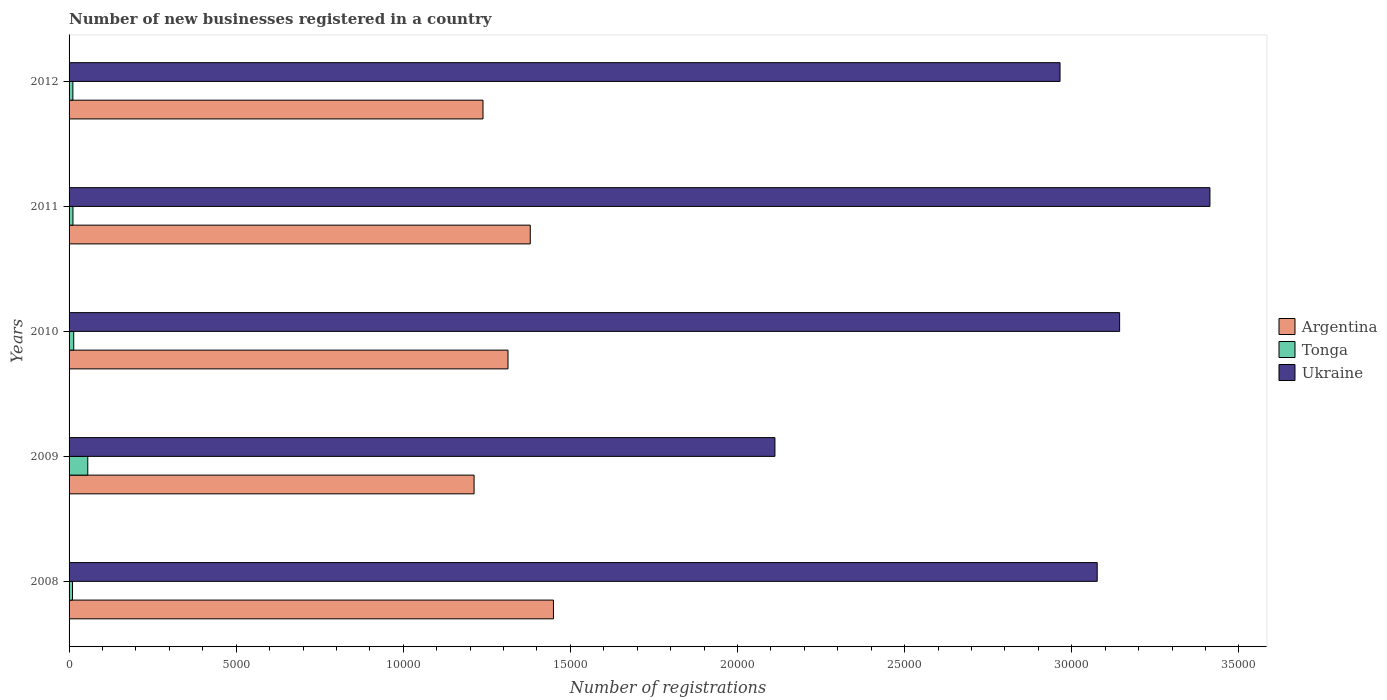How many different coloured bars are there?
Provide a succinct answer. 3. How many groups of bars are there?
Offer a very short reply. 5. Are the number of bars per tick equal to the number of legend labels?
Ensure brevity in your answer.  Yes. What is the number of new businesses registered in Ukraine in 2009?
Ensure brevity in your answer.  2.11e+04. Across all years, what is the maximum number of new businesses registered in Argentina?
Your answer should be compact. 1.45e+04. Across all years, what is the minimum number of new businesses registered in Ukraine?
Offer a very short reply. 2.11e+04. In which year was the number of new businesses registered in Argentina minimum?
Give a very brief answer. 2009. What is the total number of new businesses registered in Tonga in the graph?
Make the answer very short. 1032. What is the difference between the number of new businesses registered in Tonga in 2011 and that in 2012?
Provide a short and direct response. 2. What is the difference between the number of new businesses registered in Argentina in 2011 and the number of new businesses registered in Ukraine in 2008?
Your answer should be compact. -1.70e+04. What is the average number of new businesses registered in Ukraine per year?
Provide a succinct answer. 2.94e+04. In the year 2012, what is the difference between the number of new businesses registered in Argentina and number of new businesses registered in Tonga?
Provide a short and direct response. 1.23e+04. In how many years, is the number of new businesses registered in Argentina greater than 13000 ?
Offer a very short reply. 3. What is the ratio of the number of new businesses registered in Ukraine in 2008 to that in 2011?
Ensure brevity in your answer.  0.9. What is the difference between the highest and the second highest number of new businesses registered in Argentina?
Your answer should be very brief. 694. What is the difference between the highest and the lowest number of new businesses registered in Ukraine?
Keep it short and to the point. 1.30e+04. What does the 2nd bar from the top in 2008 represents?
Provide a succinct answer. Tonga. What does the 3rd bar from the bottom in 2008 represents?
Provide a succinct answer. Ukraine. Is it the case that in every year, the sum of the number of new businesses registered in Tonga and number of new businesses registered in Argentina is greater than the number of new businesses registered in Ukraine?
Keep it short and to the point. No. How many bars are there?
Your answer should be very brief. 15. Are all the bars in the graph horizontal?
Keep it short and to the point. Yes. Are the values on the major ticks of X-axis written in scientific E-notation?
Make the answer very short. No. Does the graph contain any zero values?
Offer a very short reply. No. Does the graph contain grids?
Give a very brief answer. No. How many legend labels are there?
Give a very brief answer. 3. How are the legend labels stacked?
Your answer should be very brief. Vertical. What is the title of the graph?
Give a very brief answer. Number of new businesses registered in a country. Does "Paraguay" appear as one of the legend labels in the graph?
Your response must be concise. No. What is the label or title of the X-axis?
Your response must be concise. Number of registrations. What is the label or title of the Y-axis?
Your response must be concise. Years. What is the Number of registrations of Argentina in 2008?
Offer a terse response. 1.45e+04. What is the Number of registrations of Tonga in 2008?
Provide a succinct answer. 103. What is the Number of registrations in Ukraine in 2008?
Offer a terse response. 3.08e+04. What is the Number of registrations of Argentina in 2009?
Ensure brevity in your answer.  1.21e+04. What is the Number of registrations in Tonga in 2009?
Your response must be concise. 560. What is the Number of registrations of Ukraine in 2009?
Your answer should be very brief. 2.11e+04. What is the Number of registrations in Argentina in 2010?
Your response must be concise. 1.31e+04. What is the Number of registrations in Tonga in 2010?
Provide a succinct answer. 139. What is the Number of registrations of Ukraine in 2010?
Offer a very short reply. 3.14e+04. What is the Number of registrations in Argentina in 2011?
Provide a succinct answer. 1.38e+04. What is the Number of registrations in Tonga in 2011?
Your answer should be compact. 116. What is the Number of registrations in Ukraine in 2011?
Your response must be concise. 3.41e+04. What is the Number of registrations of Argentina in 2012?
Offer a terse response. 1.24e+04. What is the Number of registrations of Tonga in 2012?
Offer a terse response. 114. What is the Number of registrations in Ukraine in 2012?
Provide a short and direct response. 2.96e+04. Across all years, what is the maximum Number of registrations in Argentina?
Give a very brief answer. 1.45e+04. Across all years, what is the maximum Number of registrations of Tonga?
Make the answer very short. 560. Across all years, what is the maximum Number of registrations in Ukraine?
Offer a very short reply. 3.41e+04. Across all years, what is the minimum Number of registrations of Argentina?
Offer a very short reply. 1.21e+04. Across all years, what is the minimum Number of registrations in Tonga?
Your answer should be very brief. 103. Across all years, what is the minimum Number of registrations in Ukraine?
Make the answer very short. 2.11e+04. What is the total Number of registrations in Argentina in the graph?
Keep it short and to the point. 6.59e+04. What is the total Number of registrations of Tonga in the graph?
Your response must be concise. 1032. What is the total Number of registrations in Ukraine in the graph?
Your answer should be compact. 1.47e+05. What is the difference between the Number of registrations in Argentina in 2008 and that in 2009?
Ensure brevity in your answer.  2375. What is the difference between the Number of registrations in Tonga in 2008 and that in 2009?
Give a very brief answer. -457. What is the difference between the Number of registrations in Ukraine in 2008 and that in 2009?
Your response must be concise. 9642. What is the difference between the Number of registrations of Argentina in 2008 and that in 2010?
Your answer should be very brief. 1360. What is the difference between the Number of registrations of Tonga in 2008 and that in 2010?
Offer a very short reply. -36. What is the difference between the Number of registrations of Ukraine in 2008 and that in 2010?
Your answer should be compact. -671. What is the difference between the Number of registrations of Argentina in 2008 and that in 2011?
Offer a terse response. 694. What is the difference between the Number of registrations in Tonga in 2008 and that in 2011?
Provide a short and direct response. -13. What is the difference between the Number of registrations of Ukraine in 2008 and that in 2011?
Give a very brief answer. -3373. What is the difference between the Number of registrations in Argentina in 2008 and that in 2012?
Ensure brevity in your answer.  2108. What is the difference between the Number of registrations in Ukraine in 2008 and that in 2012?
Provide a succinct answer. 1112. What is the difference between the Number of registrations in Argentina in 2009 and that in 2010?
Ensure brevity in your answer.  -1015. What is the difference between the Number of registrations in Tonga in 2009 and that in 2010?
Provide a succinct answer. 421. What is the difference between the Number of registrations in Ukraine in 2009 and that in 2010?
Offer a very short reply. -1.03e+04. What is the difference between the Number of registrations of Argentina in 2009 and that in 2011?
Your answer should be very brief. -1681. What is the difference between the Number of registrations of Tonga in 2009 and that in 2011?
Offer a terse response. 444. What is the difference between the Number of registrations in Ukraine in 2009 and that in 2011?
Your answer should be compact. -1.30e+04. What is the difference between the Number of registrations of Argentina in 2009 and that in 2012?
Your answer should be compact. -267. What is the difference between the Number of registrations of Tonga in 2009 and that in 2012?
Make the answer very short. 446. What is the difference between the Number of registrations of Ukraine in 2009 and that in 2012?
Your answer should be very brief. -8530. What is the difference between the Number of registrations in Argentina in 2010 and that in 2011?
Offer a very short reply. -666. What is the difference between the Number of registrations of Ukraine in 2010 and that in 2011?
Provide a succinct answer. -2702. What is the difference between the Number of registrations of Argentina in 2010 and that in 2012?
Keep it short and to the point. 748. What is the difference between the Number of registrations of Ukraine in 2010 and that in 2012?
Offer a terse response. 1783. What is the difference between the Number of registrations of Argentina in 2011 and that in 2012?
Your answer should be compact. 1414. What is the difference between the Number of registrations in Ukraine in 2011 and that in 2012?
Provide a short and direct response. 4485. What is the difference between the Number of registrations of Argentina in 2008 and the Number of registrations of Tonga in 2009?
Provide a short and direct response. 1.39e+04. What is the difference between the Number of registrations in Argentina in 2008 and the Number of registrations in Ukraine in 2009?
Your answer should be compact. -6627. What is the difference between the Number of registrations in Tonga in 2008 and the Number of registrations in Ukraine in 2009?
Provide a succinct answer. -2.10e+04. What is the difference between the Number of registrations in Argentina in 2008 and the Number of registrations in Tonga in 2010?
Offer a very short reply. 1.44e+04. What is the difference between the Number of registrations in Argentina in 2008 and the Number of registrations in Ukraine in 2010?
Ensure brevity in your answer.  -1.69e+04. What is the difference between the Number of registrations of Tonga in 2008 and the Number of registrations of Ukraine in 2010?
Give a very brief answer. -3.13e+04. What is the difference between the Number of registrations of Argentina in 2008 and the Number of registrations of Tonga in 2011?
Give a very brief answer. 1.44e+04. What is the difference between the Number of registrations of Argentina in 2008 and the Number of registrations of Ukraine in 2011?
Offer a very short reply. -1.96e+04. What is the difference between the Number of registrations of Tonga in 2008 and the Number of registrations of Ukraine in 2011?
Your response must be concise. -3.40e+04. What is the difference between the Number of registrations of Argentina in 2008 and the Number of registrations of Tonga in 2012?
Offer a very short reply. 1.44e+04. What is the difference between the Number of registrations of Argentina in 2008 and the Number of registrations of Ukraine in 2012?
Offer a very short reply. -1.52e+04. What is the difference between the Number of registrations of Tonga in 2008 and the Number of registrations of Ukraine in 2012?
Your answer should be very brief. -2.95e+04. What is the difference between the Number of registrations in Argentina in 2009 and the Number of registrations in Tonga in 2010?
Your answer should be compact. 1.20e+04. What is the difference between the Number of registrations in Argentina in 2009 and the Number of registrations in Ukraine in 2010?
Your answer should be compact. -1.93e+04. What is the difference between the Number of registrations of Tonga in 2009 and the Number of registrations of Ukraine in 2010?
Your answer should be very brief. -3.09e+04. What is the difference between the Number of registrations of Argentina in 2009 and the Number of registrations of Tonga in 2011?
Ensure brevity in your answer.  1.20e+04. What is the difference between the Number of registrations in Argentina in 2009 and the Number of registrations in Ukraine in 2011?
Ensure brevity in your answer.  -2.20e+04. What is the difference between the Number of registrations in Tonga in 2009 and the Number of registrations in Ukraine in 2011?
Your answer should be compact. -3.36e+04. What is the difference between the Number of registrations of Argentina in 2009 and the Number of registrations of Tonga in 2012?
Keep it short and to the point. 1.20e+04. What is the difference between the Number of registrations in Argentina in 2009 and the Number of registrations in Ukraine in 2012?
Make the answer very short. -1.75e+04. What is the difference between the Number of registrations in Tonga in 2009 and the Number of registrations in Ukraine in 2012?
Your response must be concise. -2.91e+04. What is the difference between the Number of registrations of Argentina in 2010 and the Number of registrations of Tonga in 2011?
Provide a succinct answer. 1.30e+04. What is the difference between the Number of registrations of Argentina in 2010 and the Number of registrations of Ukraine in 2011?
Keep it short and to the point. -2.10e+04. What is the difference between the Number of registrations in Tonga in 2010 and the Number of registrations in Ukraine in 2011?
Offer a very short reply. -3.40e+04. What is the difference between the Number of registrations in Argentina in 2010 and the Number of registrations in Tonga in 2012?
Give a very brief answer. 1.30e+04. What is the difference between the Number of registrations in Argentina in 2010 and the Number of registrations in Ukraine in 2012?
Give a very brief answer. -1.65e+04. What is the difference between the Number of registrations of Tonga in 2010 and the Number of registrations of Ukraine in 2012?
Provide a succinct answer. -2.95e+04. What is the difference between the Number of registrations of Argentina in 2011 and the Number of registrations of Tonga in 2012?
Make the answer very short. 1.37e+04. What is the difference between the Number of registrations of Argentina in 2011 and the Number of registrations of Ukraine in 2012?
Make the answer very short. -1.59e+04. What is the difference between the Number of registrations of Tonga in 2011 and the Number of registrations of Ukraine in 2012?
Give a very brief answer. -2.95e+04. What is the average Number of registrations in Argentina per year?
Make the answer very short. 1.32e+04. What is the average Number of registrations of Tonga per year?
Provide a succinct answer. 206.4. What is the average Number of registrations of Ukraine per year?
Your response must be concise. 2.94e+04. In the year 2008, what is the difference between the Number of registrations of Argentina and Number of registrations of Tonga?
Your answer should be very brief. 1.44e+04. In the year 2008, what is the difference between the Number of registrations of Argentina and Number of registrations of Ukraine?
Offer a terse response. -1.63e+04. In the year 2008, what is the difference between the Number of registrations of Tonga and Number of registrations of Ukraine?
Provide a succinct answer. -3.07e+04. In the year 2009, what is the difference between the Number of registrations in Argentina and Number of registrations in Tonga?
Provide a succinct answer. 1.16e+04. In the year 2009, what is the difference between the Number of registrations of Argentina and Number of registrations of Ukraine?
Make the answer very short. -9002. In the year 2009, what is the difference between the Number of registrations in Tonga and Number of registrations in Ukraine?
Provide a succinct answer. -2.06e+04. In the year 2010, what is the difference between the Number of registrations in Argentina and Number of registrations in Tonga?
Your answer should be compact. 1.30e+04. In the year 2010, what is the difference between the Number of registrations of Argentina and Number of registrations of Ukraine?
Your response must be concise. -1.83e+04. In the year 2010, what is the difference between the Number of registrations in Tonga and Number of registrations in Ukraine?
Keep it short and to the point. -3.13e+04. In the year 2011, what is the difference between the Number of registrations in Argentina and Number of registrations in Tonga?
Make the answer very short. 1.37e+04. In the year 2011, what is the difference between the Number of registrations in Argentina and Number of registrations in Ukraine?
Your answer should be compact. -2.03e+04. In the year 2011, what is the difference between the Number of registrations in Tonga and Number of registrations in Ukraine?
Make the answer very short. -3.40e+04. In the year 2012, what is the difference between the Number of registrations of Argentina and Number of registrations of Tonga?
Offer a very short reply. 1.23e+04. In the year 2012, what is the difference between the Number of registrations of Argentina and Number of registrations of Ukraine?
Your response must be concise. -1.73e+04. In the year 2012, what is the difference between the Number of registrations in Tonga and Number of registrations in Ukraine?
Give a very brief answer. -2.95e+04. What is the ratio of the Number of registrations in Argentina in 2008 to that in 2009?
Keep it short and to the point. 1.2. What is the ratio of the Number of registrations in Tonga in 2008 to that in 2009?
Your answer should be compact. 0.18. What is the ratio of the Number of registrations in Ukraine in 2008 to that in 2009?
Your response must be concise. 1.46. What is the ratio of the Number of registrations of Argentina in 2008 to that in 2010?
Provide a succinct answer. 1.1. What is the ratio of the Number of registrations in Tonga in 2008 to that in 2010?
Give a very brief answer. 0.74. What is the ratio of the Number of registrations of Ukraine in 2008 to that in 2010?
Give a very brief answer. 0.98. What is the ratio of the Number of registrations in Argentina in 2008 to that in 2011?
Your answer should be very brief. 1.05. What is the ratio of the Number of registrations of Tonga in 2008 to that in 2011?
Ensure brevity in your answer.  0.89. What is the ratio of the Number of registrations of Ukraine in 2008 to that in 2011?
Your answer should be very brief. 0.9. What is the ratio of the Number of registrations in Argentina in 2008 to that in 2012?
Your answer should be compact. 1.17. What is the ratio of the Number of registrations in Tonga in 2008 to that in 2012?
Your answer should be compact. 0.9. What is the ratio of the Number of registrations in Ukraine in 2008 to that in 2012?
Ensure brevity in your answer.  1.04. What is the ratio of the Number of registrations of Argentina in 2009 to that in 2010?
Make the answer very short. 0.92. What is the ratio of the Number of registrations in Tonga in 2009 to that in 2010?
Ensure brevity in your answer.  4.03. What is the ratio of the Number of registrations in Ukraine in 2009 to that in 2010?
Keep it short and to the point. 0.67. What is the ratio of the Number of registrations of Argentina in 2009 to that in 2011?
Offer a very short reply. 0.88. What is the ratio of the Number of registrations in Tonga in 2009 to that in 2011?
Offer a very short reply. 4.83. What is the ratio of the Number of registrations in Ukraine in 2009 to that in 2011?
Give a very brief answer. 0.62. What is the ratio of the Number of registrations in Argentina in 2009 to that in 2012?
Keep it short and to the point. 0.98. What is the ratio of the Number of registrations in Tonga in 2009 to that in 2012?
Provide a short and direct response. 4.91. What is the ratio of the Number of registrations of Ukraine in 2009 to that in 2012?
Make the answer very short. 0.71. What is the ratio of the Number of registrations in Argentina in 2010 to that in 2011?
Offer a terse response. 0.95. What is the ratio of the Number of registrations of Tonga in 2010 to that in 2011?
Give a very brief answer. 1.2. What is the ratio of the Number of registrations of Ukraine in 2010 to that in 2011?
Offer a terse response. 0.92. What is the ratio of the Number of registrations in Argentina in 2010 to that in 2012?
Ensure brevity in your answer.  1.06. What is the ratio of the Number of registrations in Tonga in 2010 to that in 2012?
Offer a very short reply. 1.22. What is the ratio of the Number of registrations in Ukraine in 2010 to that in 2012?
Offer a very short reply. 1.06. What is the ratio of the Number of registrations of Argentina in 2011 to that in 2012?
Provide a succinct answer. 1.11. What is the ratio of the Number of registrations in Tonga in 2011 to that in 2012?
Offer a very short reply. 1.02. What is the ratio of the Number of registrations of Ukraine in 2011 to that in 2012?
Provide a short and direct response. 1.15. What is the difference between the highest and the second highest Number of registrations in Argentina?
Keep it short and to the point. 694. What is the difference between the highest and the second highest Number of registrations in Tonga?
Provide a short and direct response. 421. What is the difference between the highest and the second highest Number of registrations in Ukraine?
Your answer should be very brief. 2702. What is the difference between the highest and the lowest Number of registrations in Argentina?
Keep it short and to the point. 2375. What is the difference between the highest and the lowest Number of registrations of Tonga?
Your answer should be compact. 457. What is the difference between the highest and the lowest Number of registrations in Ukraine?
Your answer should be very brief. 1.30e+04. 